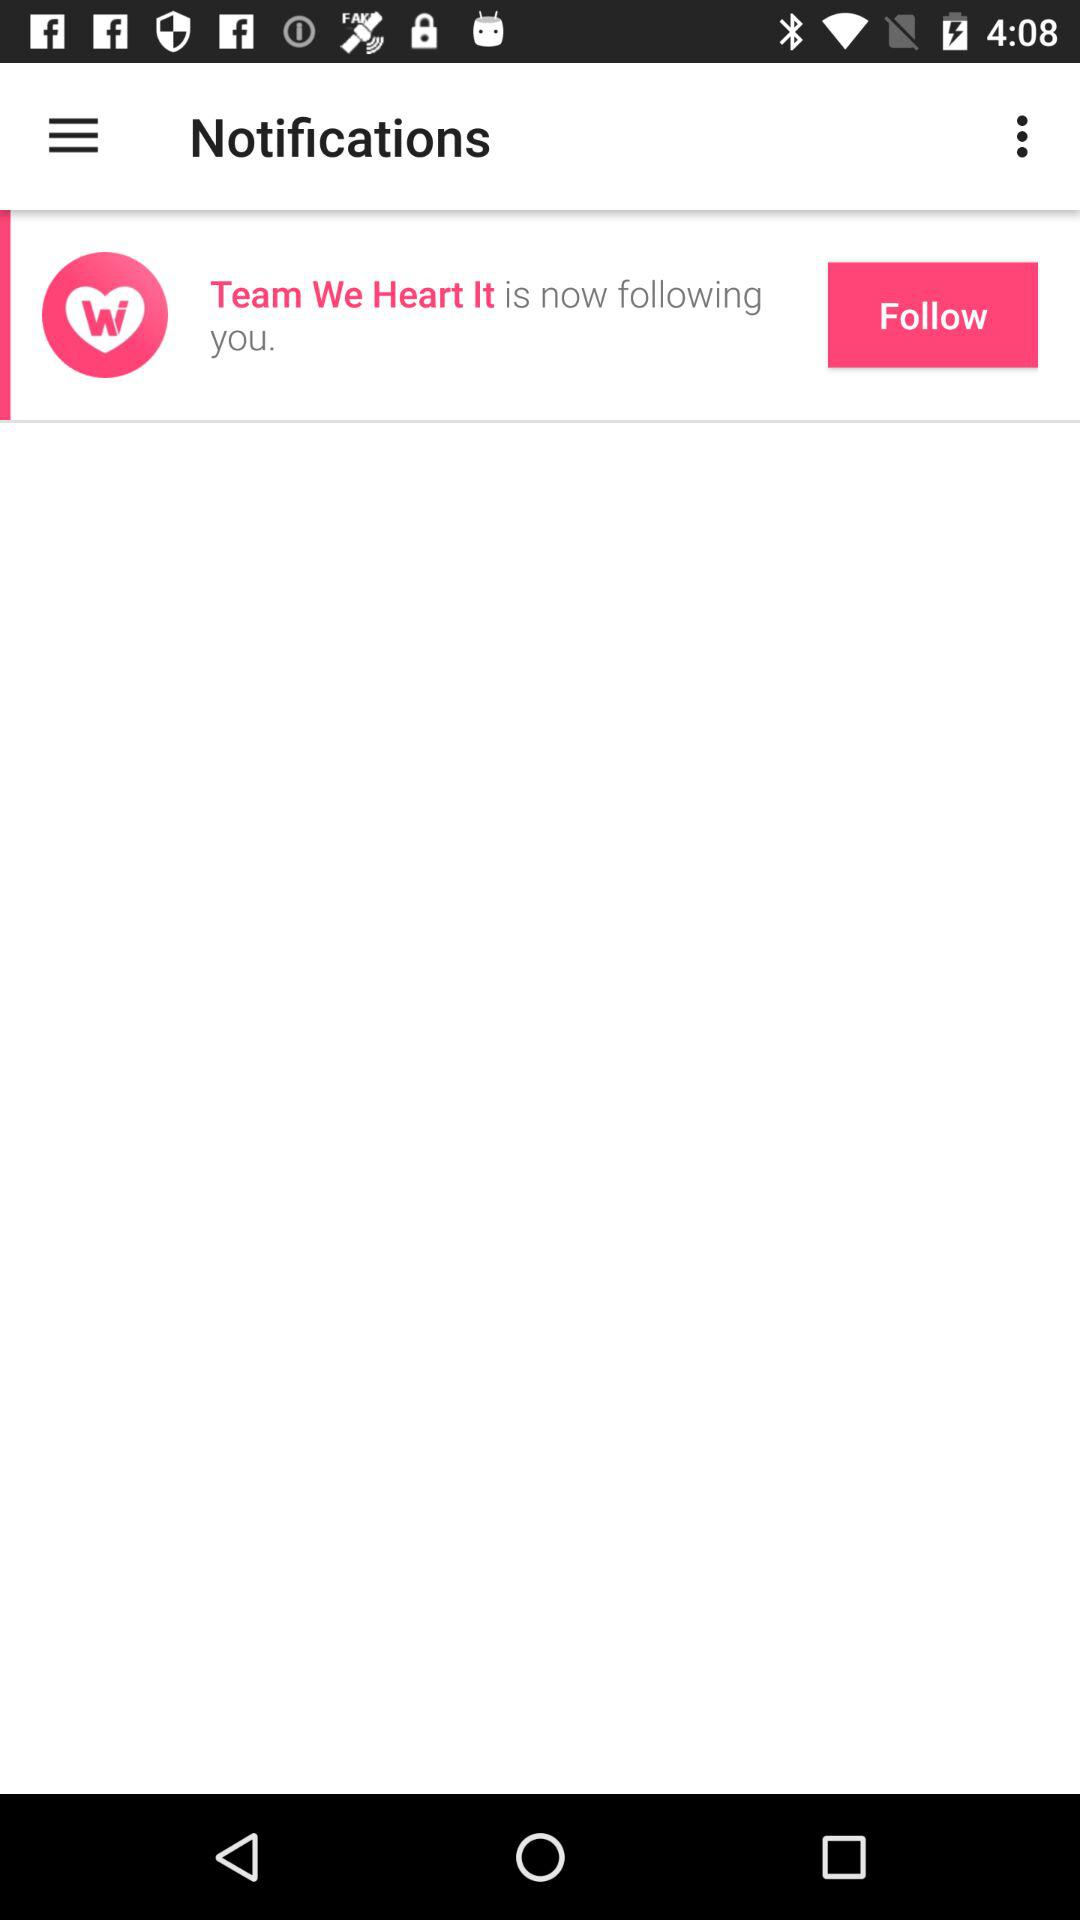Who is the new follower? The new follower is "Team We Heart It". 